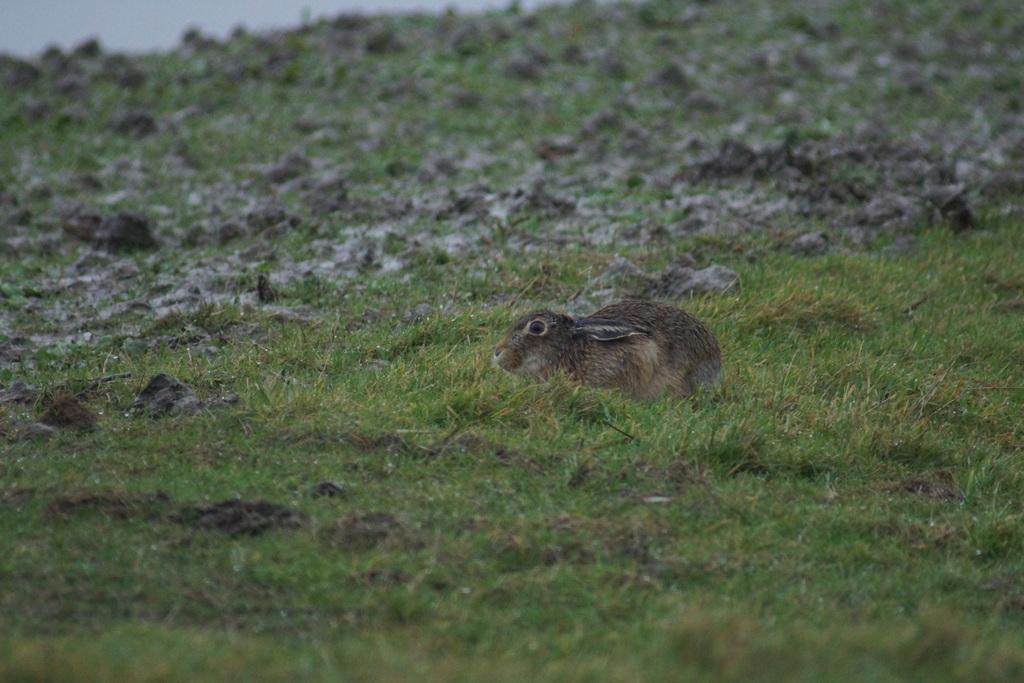What is the main subject in the middle of the picture? There is an animal in the middle of the picture. What type of animal does it resemble? The animal looks like a rabbit. What is the ground surface like in the image? There is grass visible on the ground in the image. What shape is the store in the image? There is no store present in the image; it features an animal that resembles a rabbit and grass on the ground. 